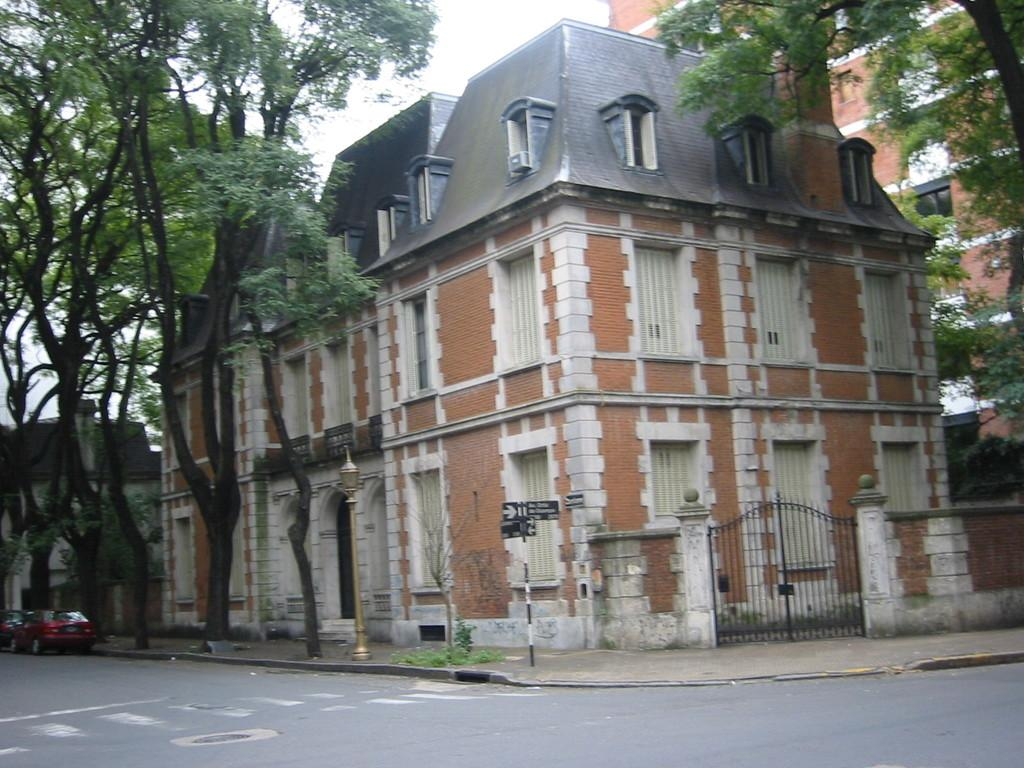What can be seen on the road in the image? There are vehicles on the road in the image. What type of path is present for pedestrians? There is a footpath in the image. What structure is present in the image that might control access? There is a gate in the image. What is attached to a pole in the image that provides information? Name boards are attached to a pole in the image. What type of structure is present in the image that provides illumination? There is a light pole in the image. What type of vegetation is present in the image? Trees are present in the image. What type of man-made structures are visible in the image? There are buildings in the image. What architectural features can be seen on the buildings? Windows are visible in the image. What is visible in the background of the image? The sky is visible in the background of the image. Can you see a ladybug playing a game on the top of the light pole in the image? No, there is no ladybug or game present on the light pole in the image. 